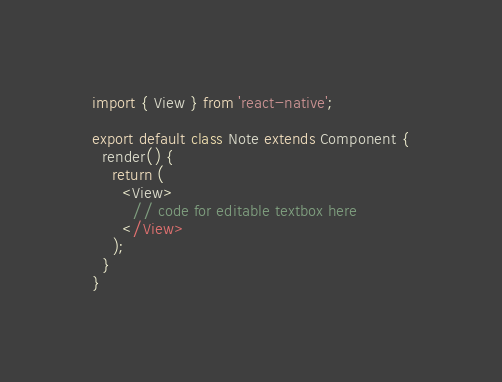Convert code to text. <code><loc_0><loc_0><loc_500><loc_500><_JavaScript_>import { View } from 'react-native';

export default class Note extends Component {
  render() {
    return (
      <View>
        // code for editable textbox here
      </View>
    );
  }
}
</code> 